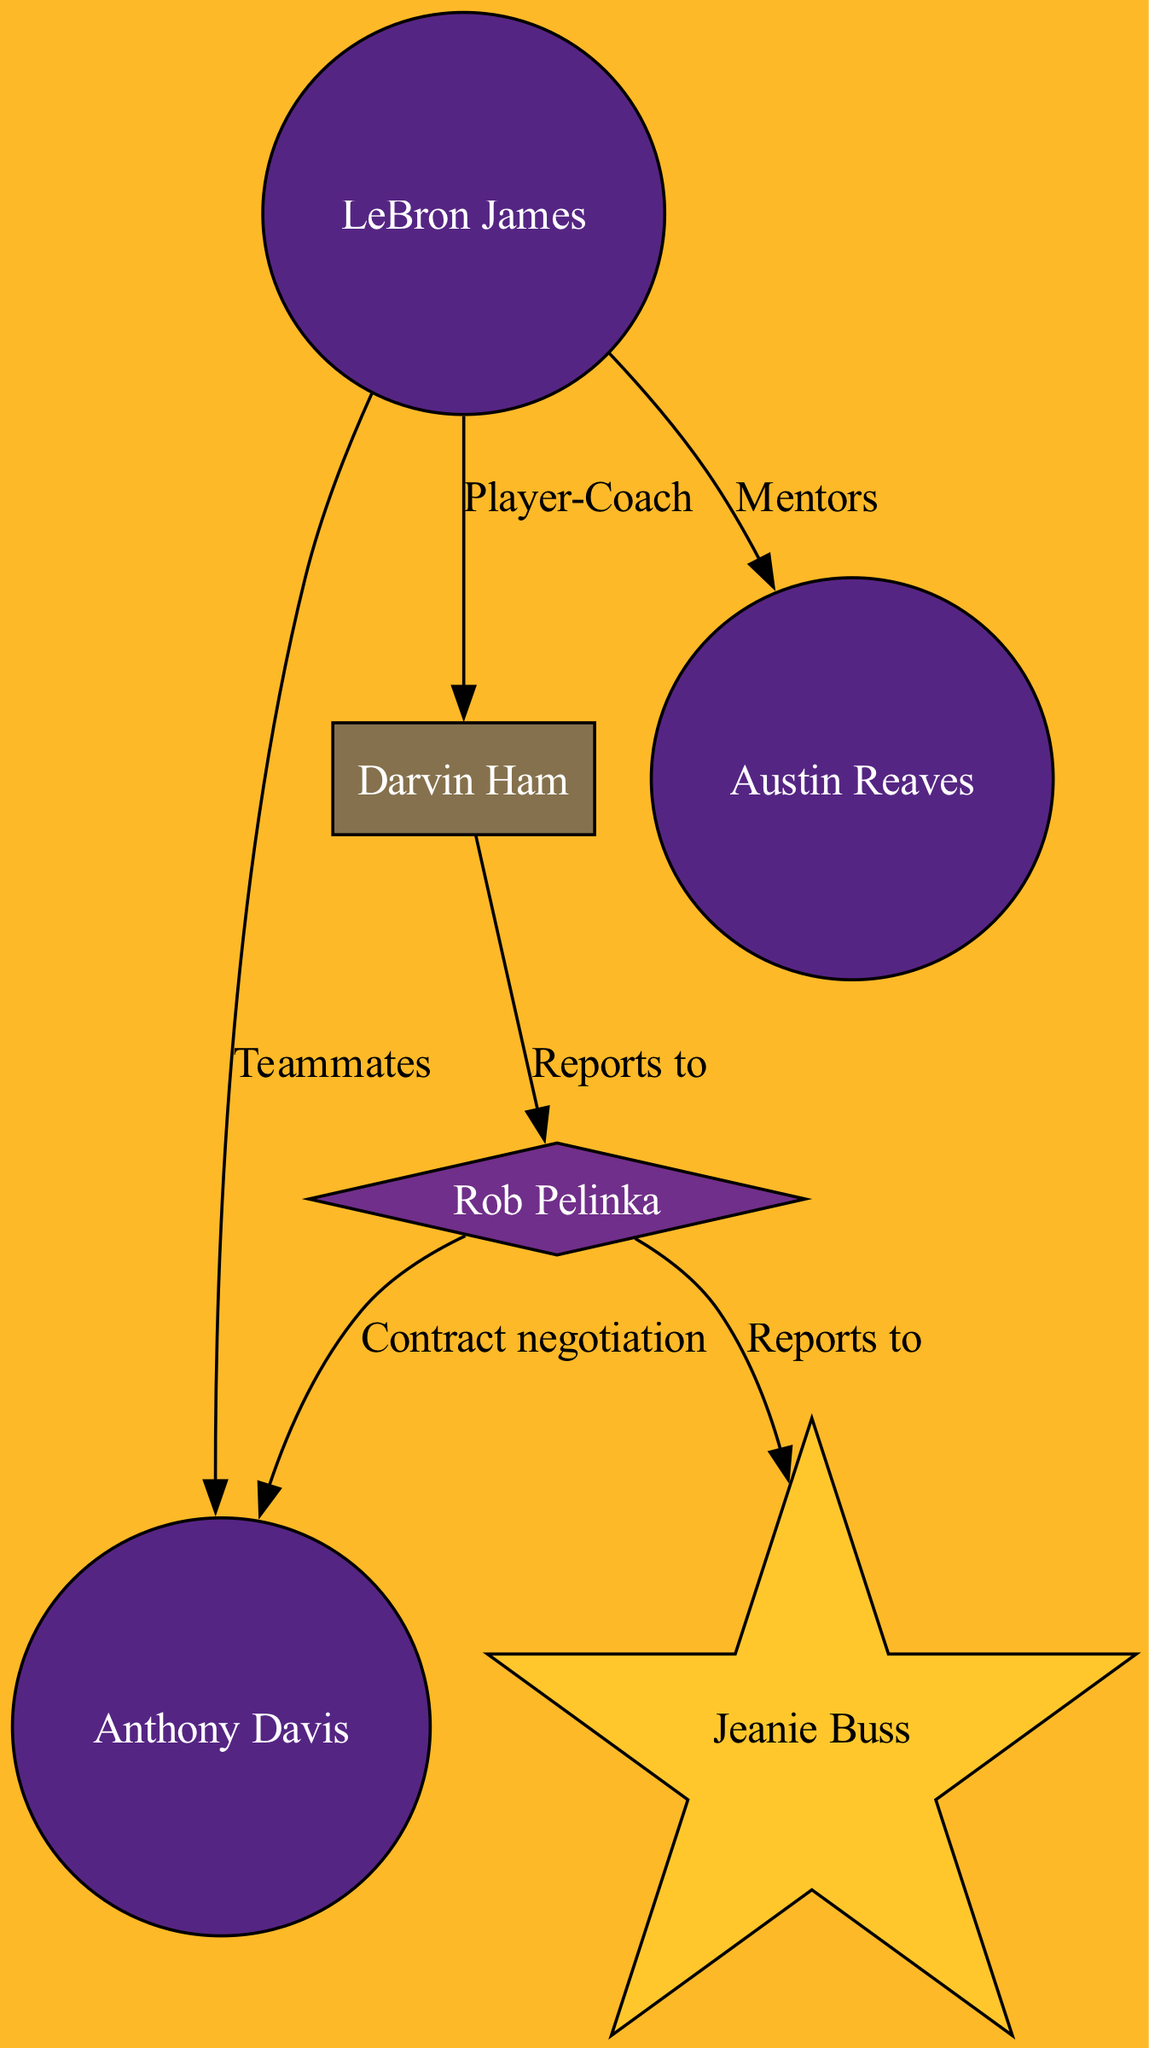What is the label for the node with ID "1"? The diagram shows that the node corresponding to ID "1" is labeled "LeBron James." This information is directly retrievable from the nodes data in the diagram.
Answer: LeBron James How many players are represented in the diagram? The diagram includes three nodes classified as "Player": LeBron James, Anthony Davis, and Austin Reaves. Counting these nodes gives a total of three players.
Answer: 3 What type of connection exists between LeBron James and Darvin Ham? According to the edges in the diagram, the connection between LeBron James (ID "1") and Darvin Ham (ID "3") is labeled "Player-Coach." This specifies the type of relationship they share.
Answer: Player-Coach Who does Rob Pelinka report to? The diagram indicates that Rob Pelinka (ID "4") has a directional edge that connects to Jeanie Buss (ID "5") with the label "Reports to." This shows that Pelinka reports to Buss.
Answer: Jeanie Buss What is the nature of the relationship between Anthony Davis and Rob Pelinka? The diagram shows a connection that describes "Contract negotiation" between Anthony Davis (ID "2") and Rob Pelinka (ID "4"). This relationship indicates the context of their interaction.
Answer: Contract negotiation Which node colors represent the players in the diagram? In the diagram, the player nodes are filled with "Lakers purple" based on the color scheme provided for nodes categorized as "Player." This is a distinct feature of how players are visually represented.
Answer: Lakers purple How many edges are present in the diagram? To determine the number of edges, we can count each relationship shown in the edges data. There are six edges listed, representing various connections among the nodes.
Answer: 6 Which node is considered the owner of the team? The diagram identifies Jeanie Buss (ID "5") as the "Owner" node. This is a specific designation found in the nodes data of the diagram.
Answer: Jeanie Buss What type is the node for Darvin Ham? The node for Darvin Ham (ID "3") is classified as "Head Coach." This type is explicitly mentioned in the nodes section, defining his role within the organization.
Answer: Head Coach 